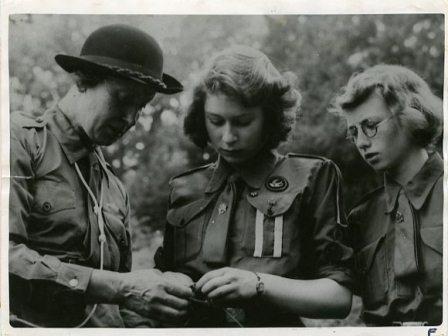What organization is the man's outfit from?
Select the accurate response from the four choices given to answer the question.
Options: Firefighters, paramedics, boy scouts, navy. Boy scouts. 